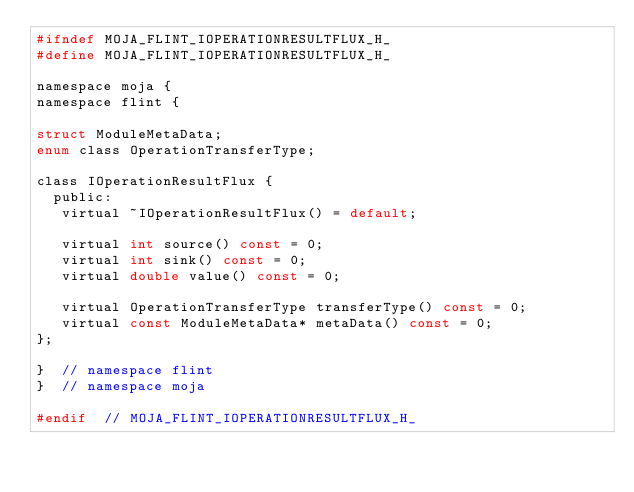Convert code to text. <code><loc_0><loc_0><loc_500><loc_500><_C_>#ifndef MOJA_FLINT_IOPERATIONRESULTFLUX_H_
#define MOJA_FLINT_IOPERATIONRESULTFLUX_H_

namespace moja {
namespace flint {

struct ModuleMetaData;
enum class OperationTransferType;

class IOperationResultFlux {
  public:
   virtual ~IOperationResultFlux() = default;

   virtual int source() const = 0;
   virtual int sink() const = 0;
   virtual double value() const = 0;

   virtual OperationTransferType transferType() const = 0;
   virtual const ModuleMetaData* metaData() const = 0;
};

}  // namespace flint
}  // namespace moja

#endif  // MOJA_FLINT_IOPERATIONRESULTFLUX_H_
</code> 